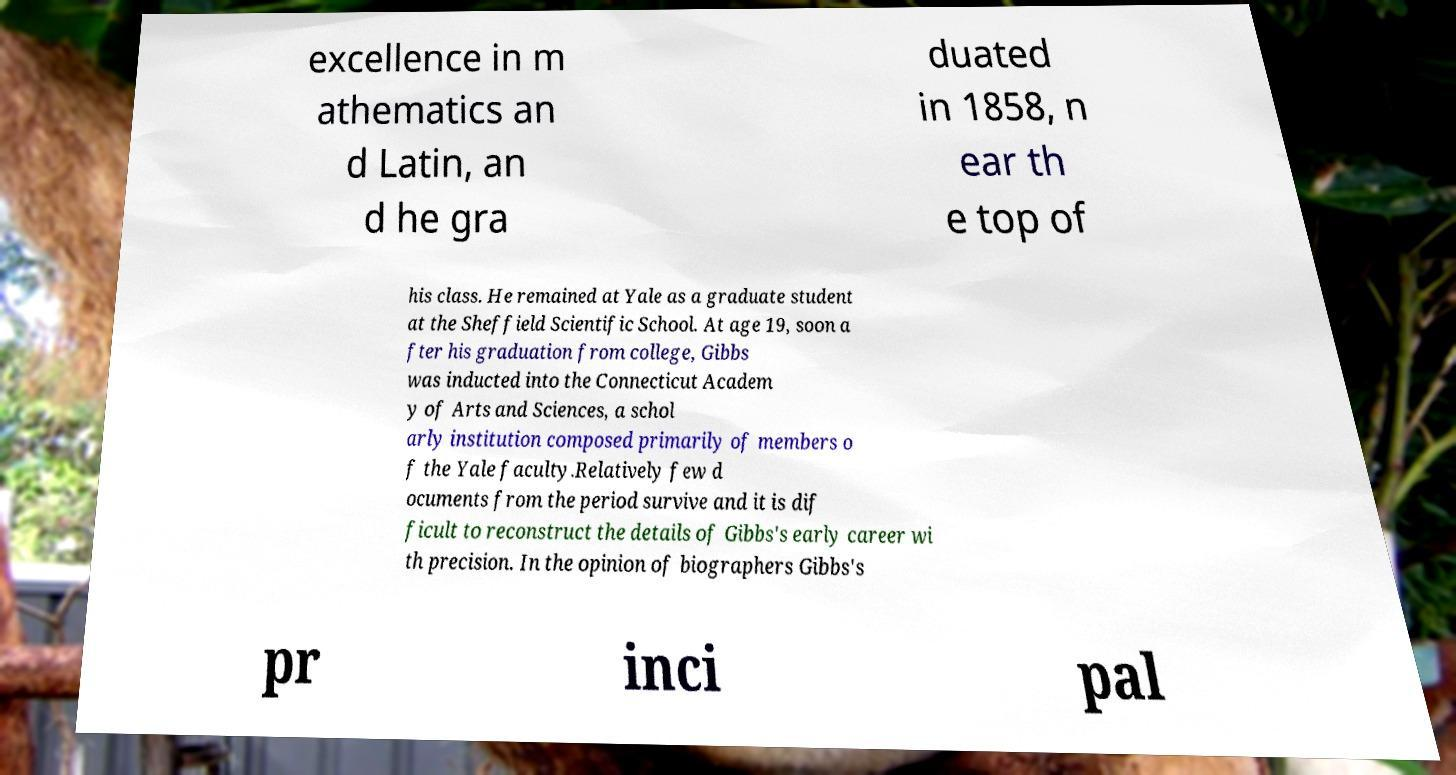What messages or text are displayed in this image? I need them in a readable, typed format. excellence in m athematics an d Latin, an d he gra duated in 1858, n ear th e top of his class. He remained at Yale as a graduate student at the Sheffield Scientific School. At age 19, soon a fter his graduation from college, Gibbs was inducted into the Connecticut Academ y of Arts and Sciences, a schol arly institution composed primarily of members o f the Yale faculty.Relatively few d ocuments from the period survive and it is dif ficult to reconstruct the details of Gibbs's early career wi th precision. In the opinion of biographers Gibbs's pr inci pal 